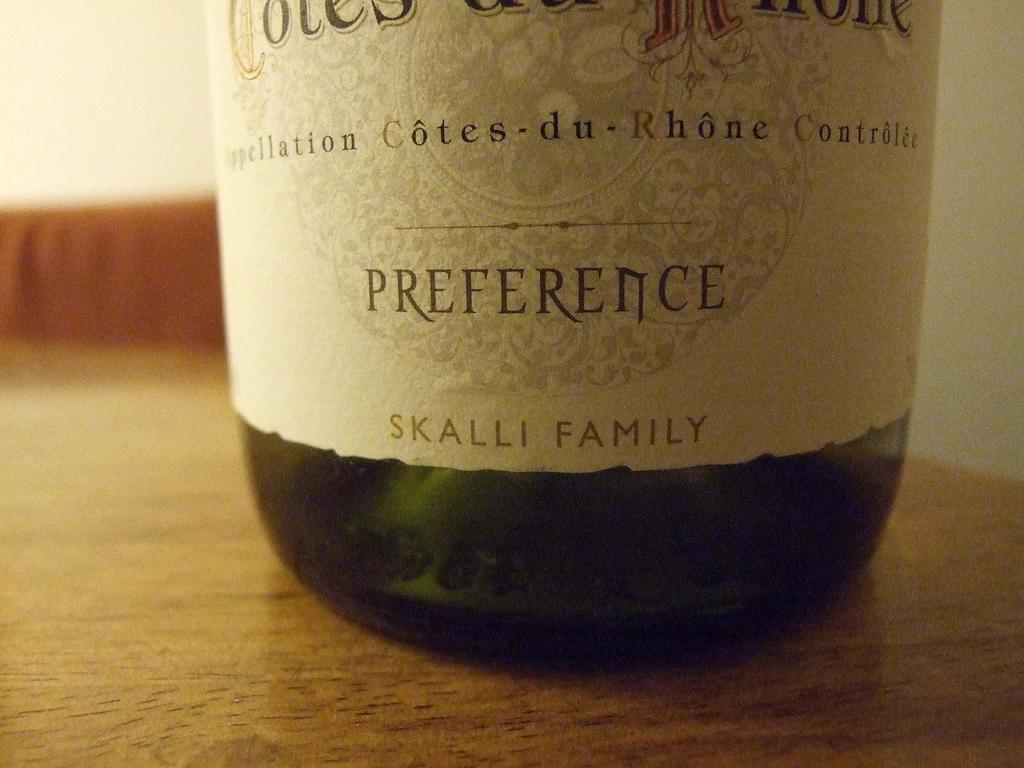<image>
Provide a brief description of the given image. Bottle of alcohol that says SKALLI FAMILY on it sitting on top of a table. 